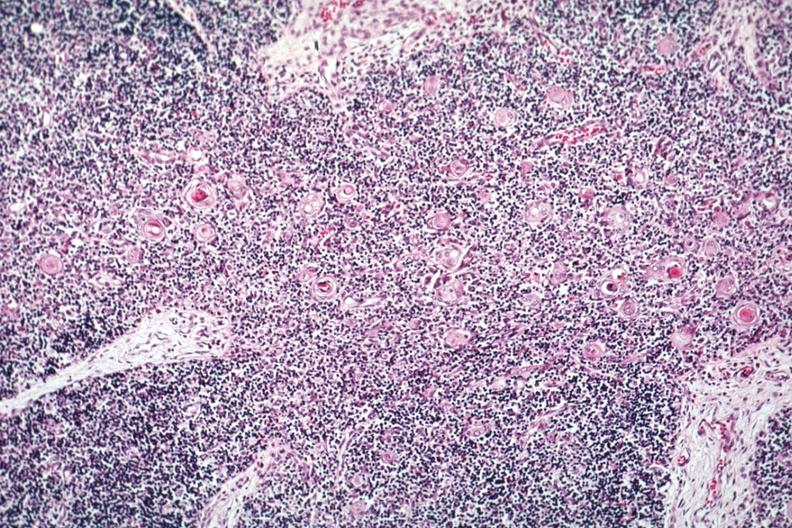what is present?
Answer the question using a single word or phrase. Hematologic 